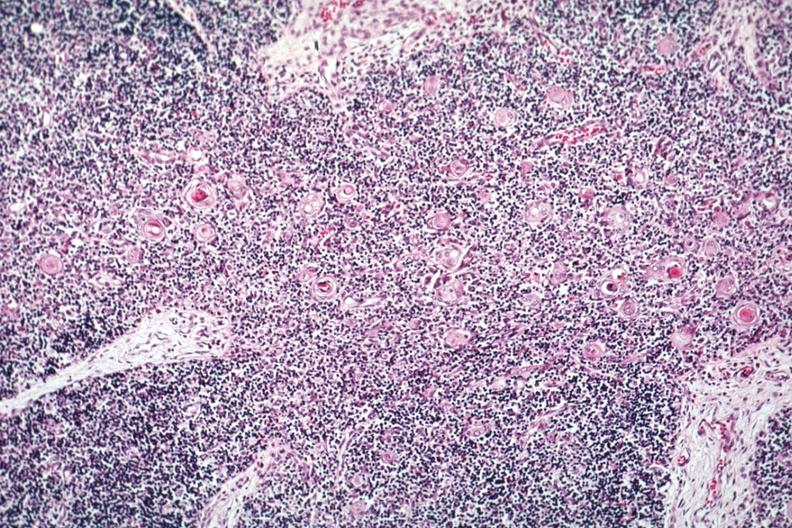what is present?
Answer the question using a single word or phrase. Hematologic 